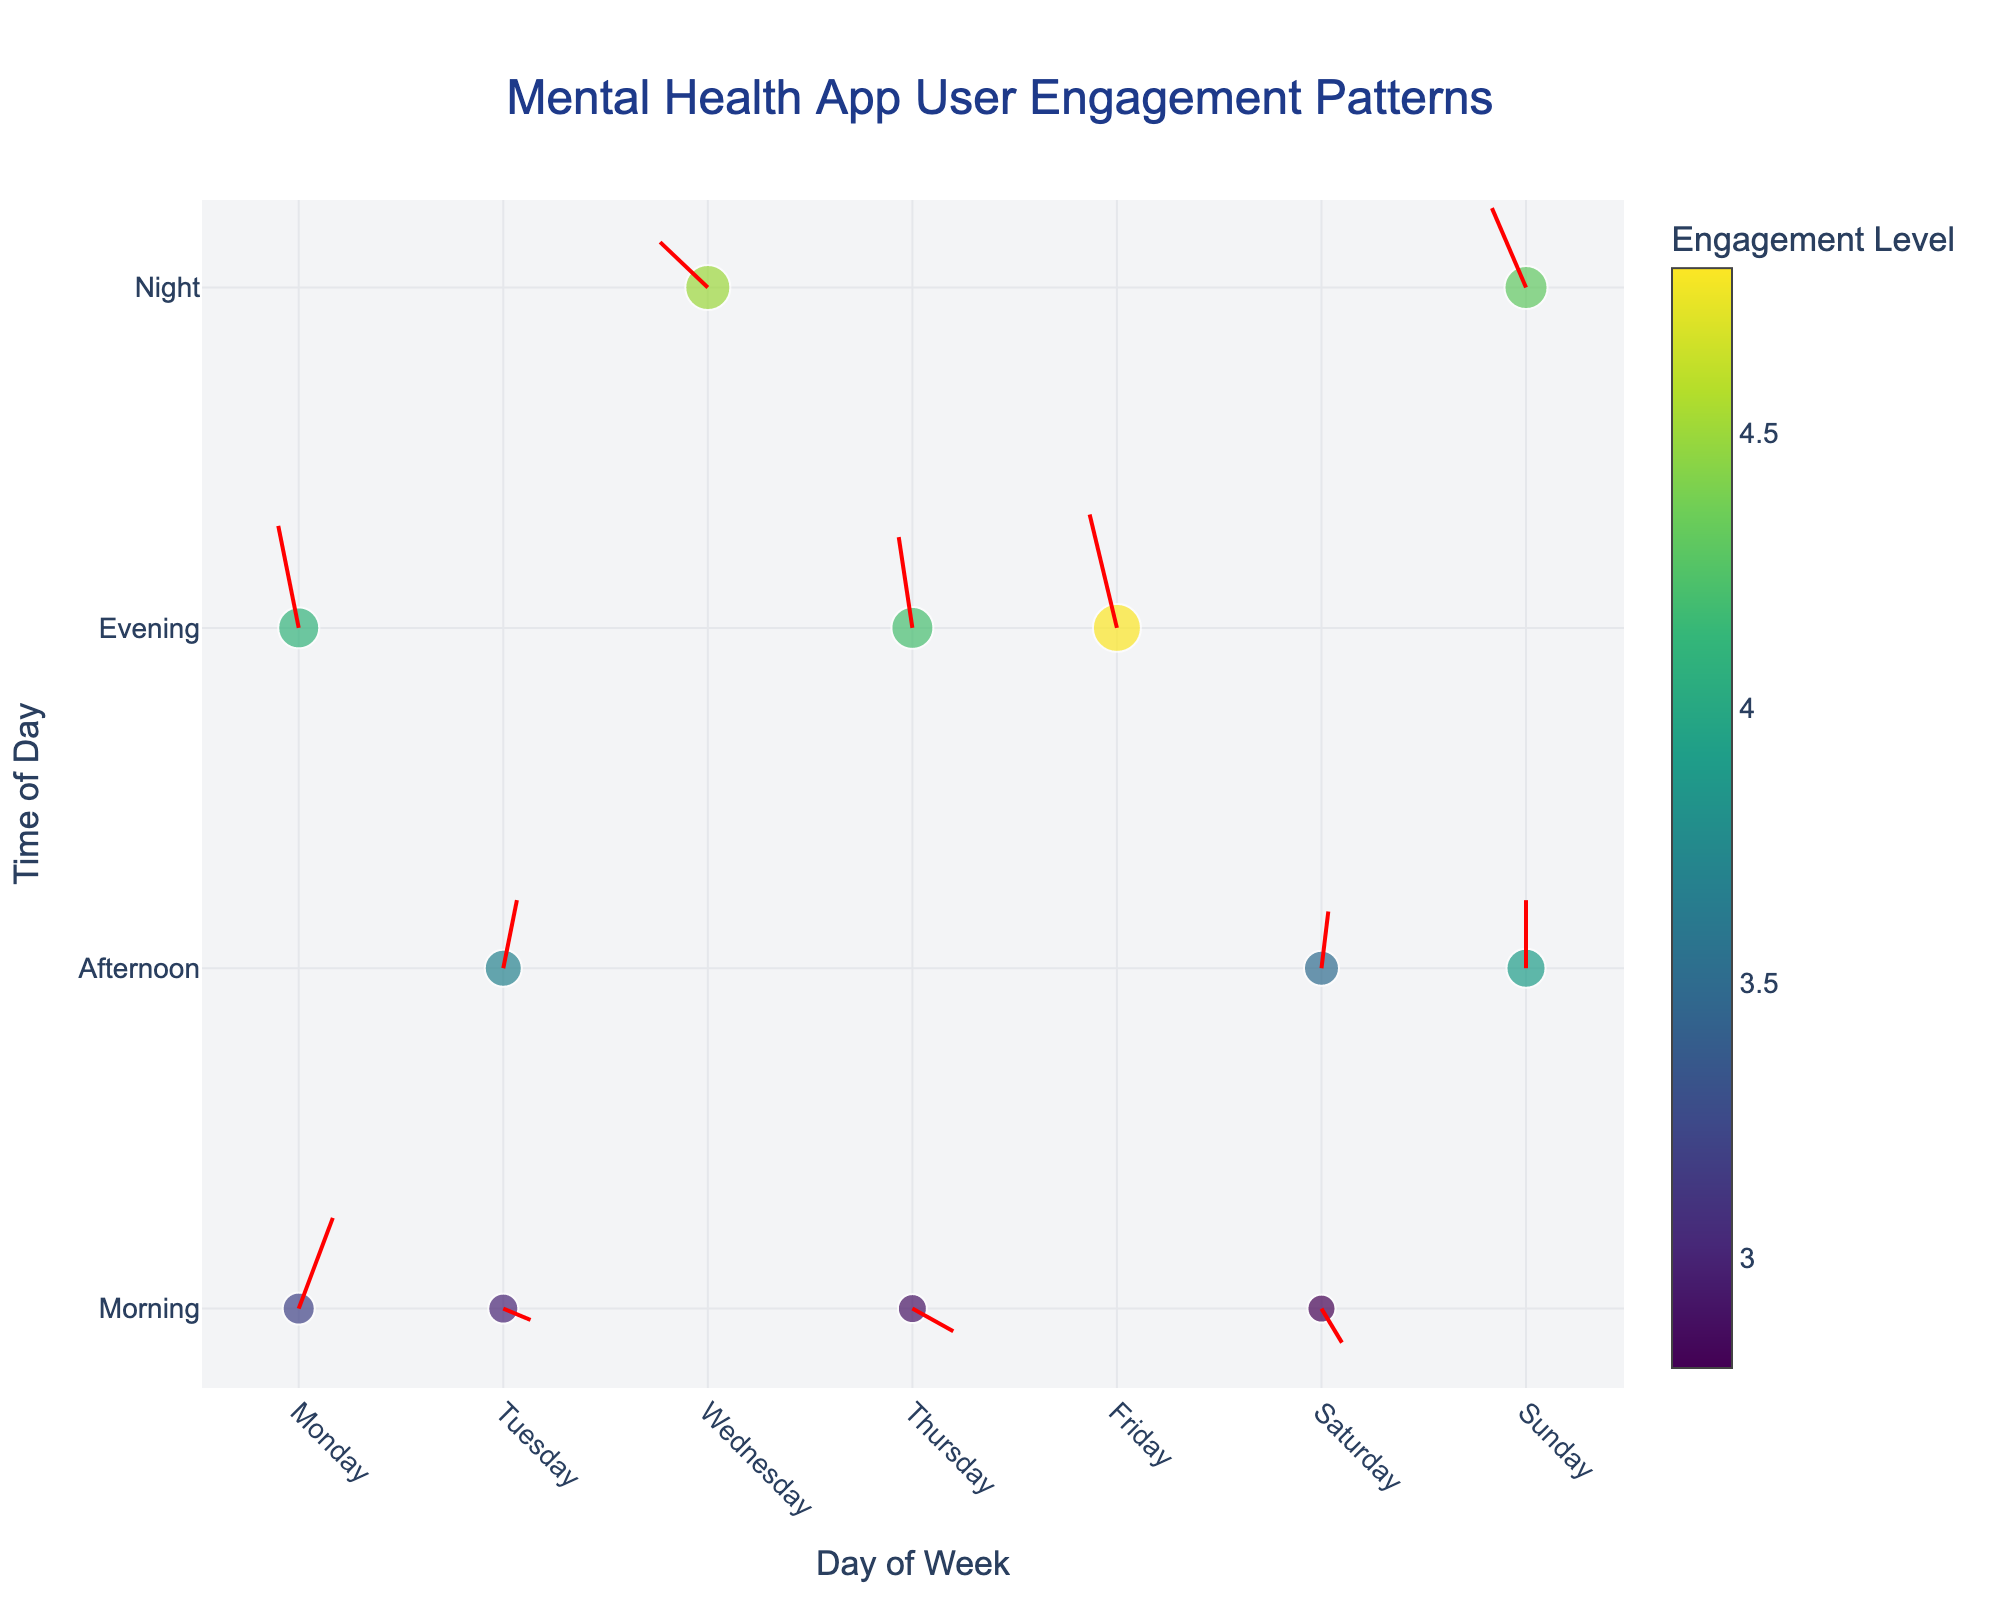What is the title of the plot? The title of the plot is displayed at the top of the figure and it reads "Mental Health App User Engagement Patterns".
Answer: Mental Health App User Engagement Patterns How many times does 'Night' appear in the plot? To count the occurrences of 'Night', look at the y-axis labeled 'Time of Day' and count how many markers align with 'Night'. There are three instances of 'Night' in the plot.
Answer: 3 Which day shows the highest engagement level? Look for the largest marker in the plot, which represents the highest engagement level according to the colorbar scale. This occurs on Friday Evening.
Answer: Friday What is the engagement level on Sunday Afternoon? Hover over or observe the marker tied to 'Sunday' on the x-axis and 'Afternoon' on the y-axis. The engagement level displayed is 3.9.
Answer: 3.9 In which direction does user engagement change on Wednesday Night? Find the marker corresponding to Wednesday Night, then examine the direction of the arrow stemming from it. The arrow points left and slightly up (-0.7, 0.4).
Answer: Left and slightly up What is the average engagement level on mornings? Collect the engagement levels for all time points marked as 'Morning', which are 3.2, 3.0, and 2.8. Compute the average: (3.2 + 3.0 + 2.8)/3 = 3.0.
Answer: 3.0 Which time of day shows the most variability in engagement levels? Compare the range of engagement levels for each time of day by observing the size variations of markers within each time category. Evening shows the most variability, from 4.1 to 4.8.
Answer: Evening Compare the direction of engagement changes on Monday Evening and Friday Evening. Which direction is more upward? Look at the directions indicated by arrows for both times. Monday Evening shows (-0.3, 0.9) and Friday Evening shows (-0.4, 1.0). Since 0.9 < 1.0, Friday Evening's direction is more upward.
Answer: Friday Evening Which day and time combination shows an engagement level of 4.2? Hover over the markers and match the engagement level to 4.2. The combination is Thursday Evening.
Answer: Thursday Evening What is the overall trend in engagement level changes from Morning to Evening throughout the week? From Monday Morning to Sunday Evening, compare the sizes and directions of the arrows. Engagement tends to increase towards Evening, with larger markers and more upward arrows.
Answer: Increase towards Evening 